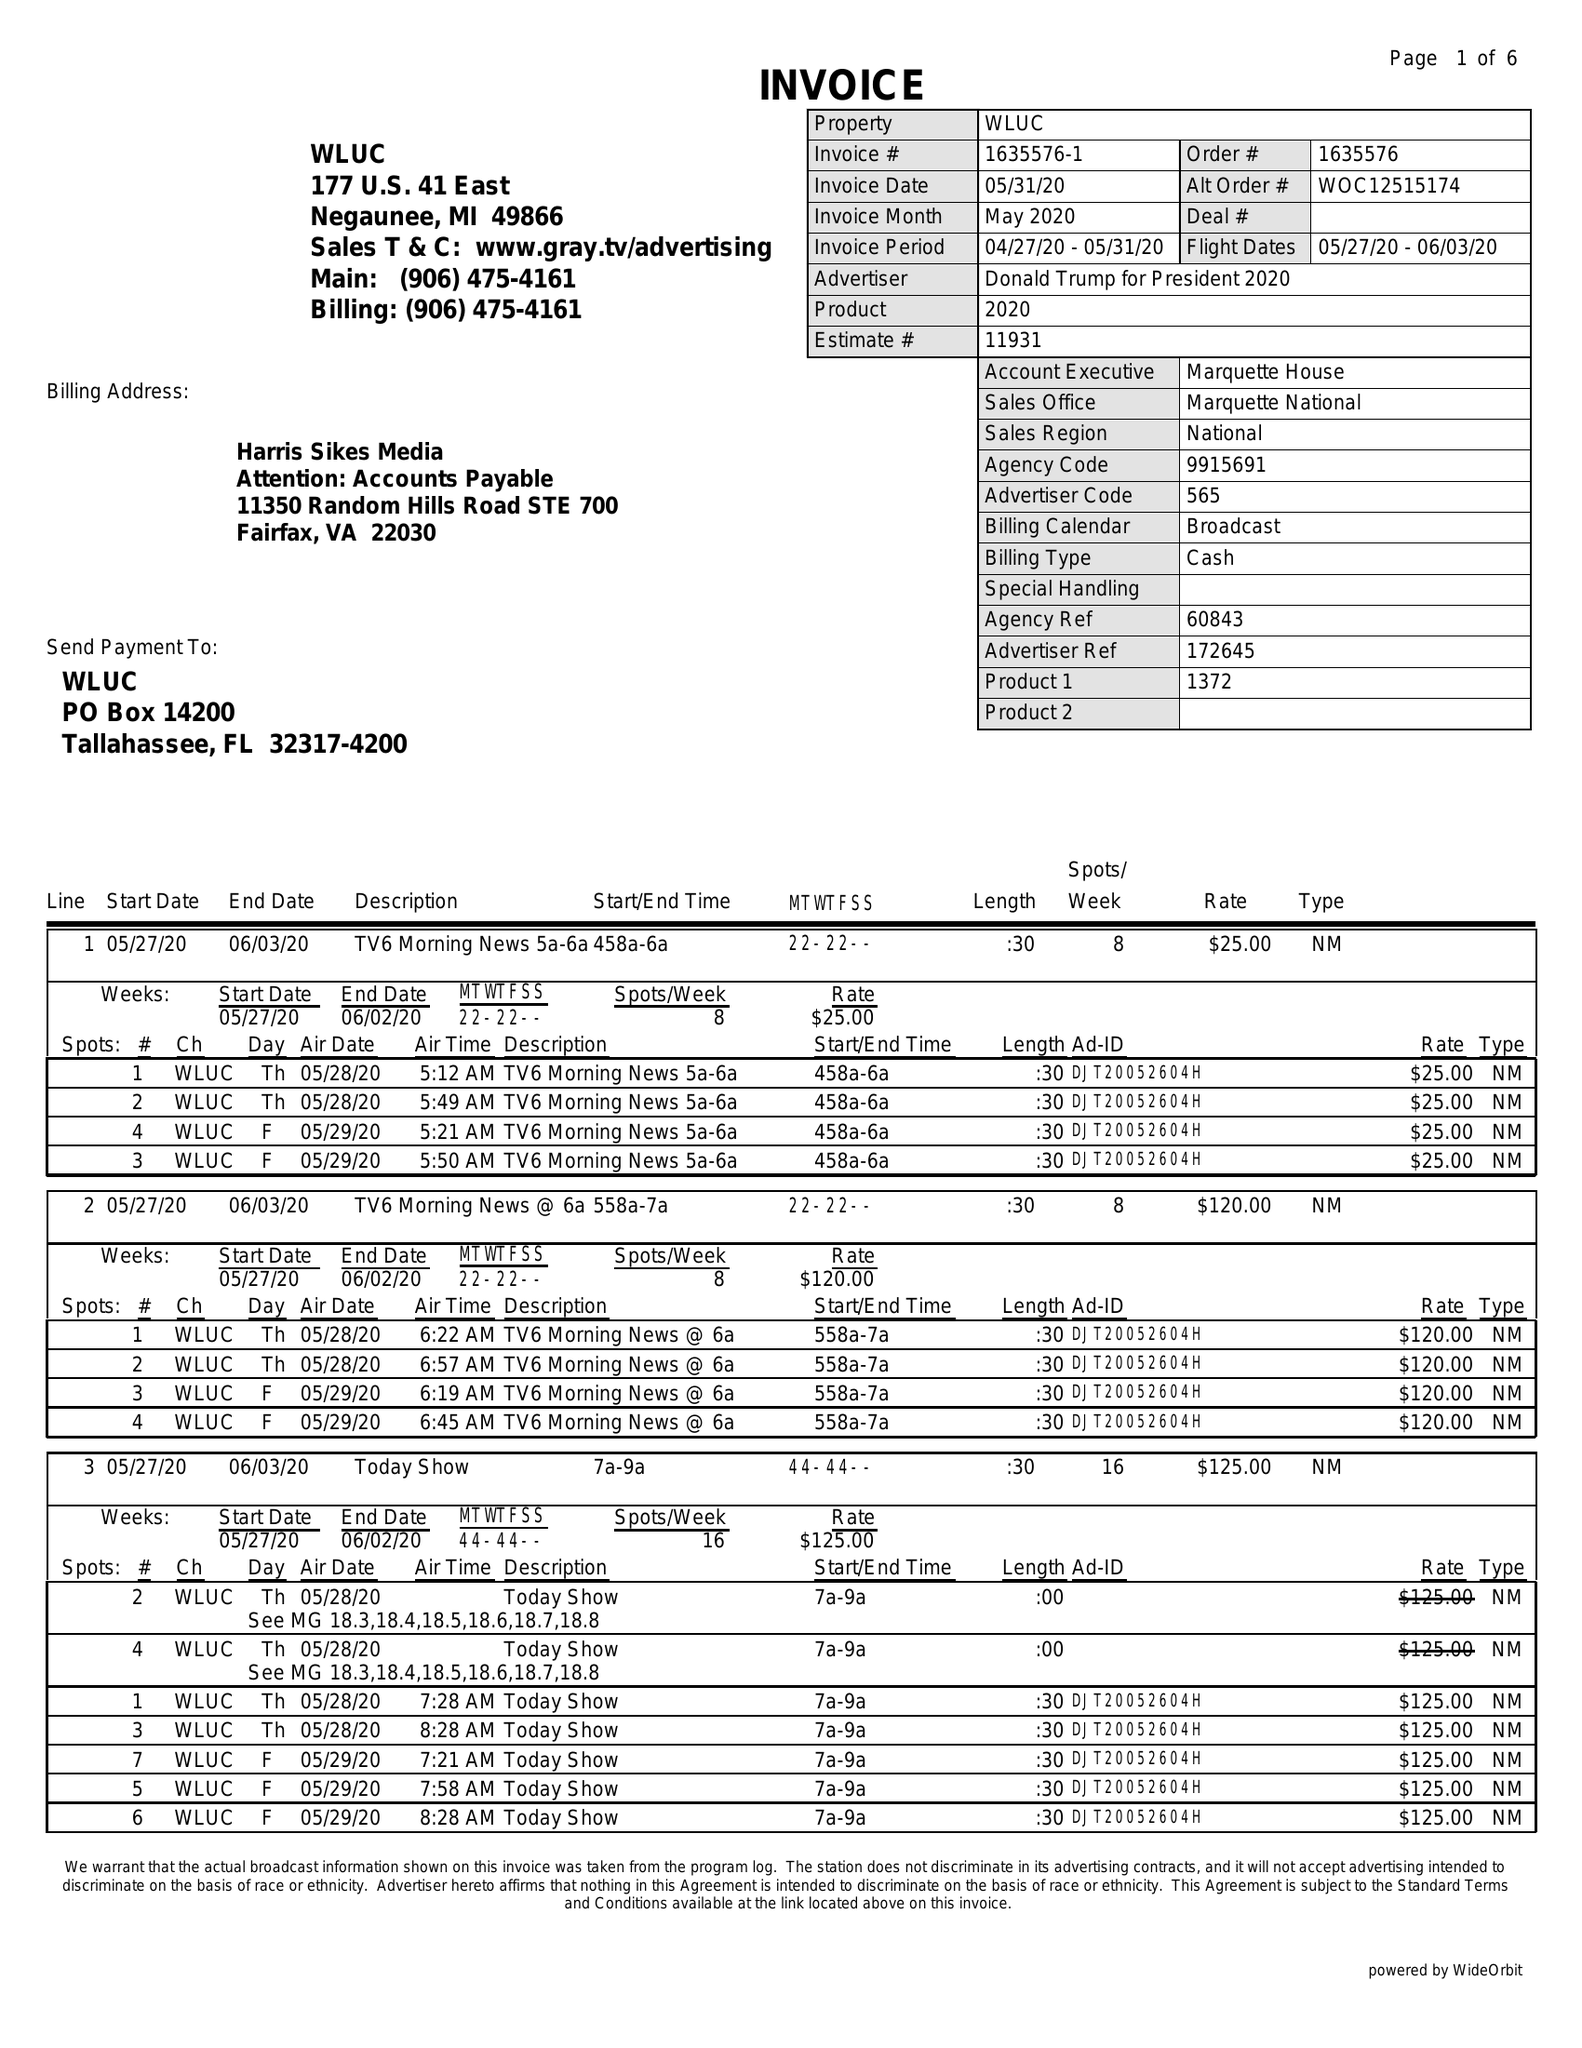What is the value for the advertiser?
Answer the question using a single word or phrase. DONALD TRUMP FOR PRESIDENT 2020 